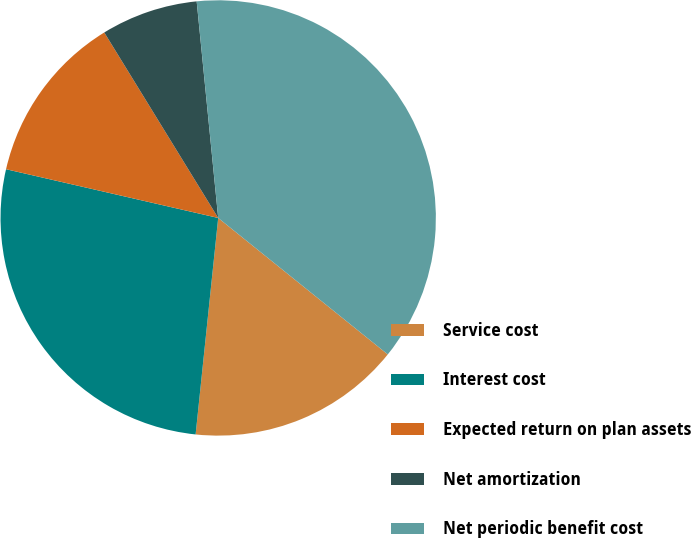Convert chart to OTSL. <chart><loc_0><loc_0><loc_500><loc_500><pie_chart><fcel>Service cost<fcel>Interest cost<fcel>Expected return on plan assets<fcel>Net amortization<fcel>Net periodic benefit cost<nl><fcel>15.87%<fcel>26.94%<fcel>12.64%<fcel>7.19%<fcel>37.36%<nl></chart> 